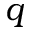<formula> <loc_0><loc_0><loc_500><loc_500>q</formula> 